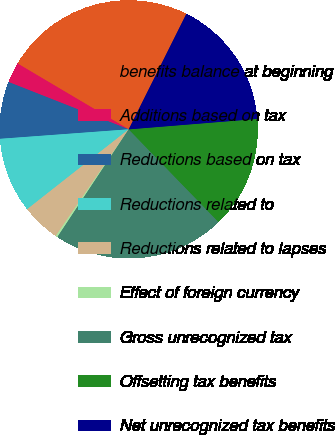Convert chart to OTSL. <chart><loc_0><loc_0><loc_500><loc_500><pie_chart><fcel>benefits balance at beginning<fcel>Additions based on tax<fcel>Reductions based on tax<fcel>Reductions related to<fcel>Reductions related to lapses<fcel>Effect of foreign currency<fcel>Gross unrecognized tax<fcel>Offsetting tax benefits<fcel>Net unrecognized tax benefits<nl><fcel>23.86%<fcel>2.54%<fcel>7.14%<fcel>9.44%<fcel>4.84%<fcel>0.24%<fcel>21.56%<fcel>14.04%<fcel>16.34%<nl></chart> 